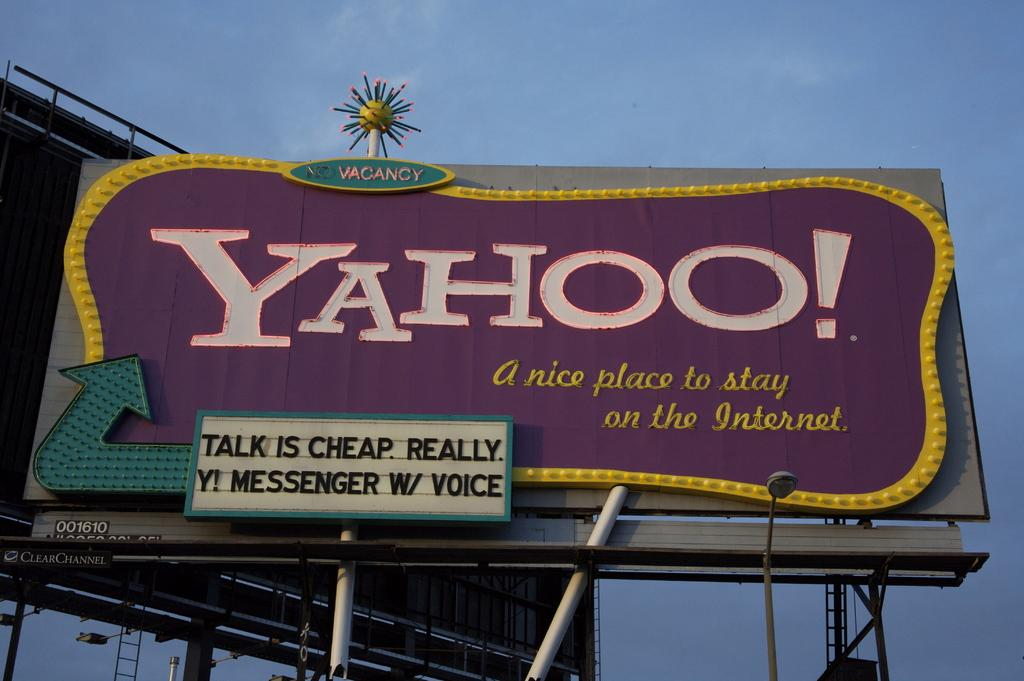<image>
Write a terse but informative summary of the picture. A Yahoo logo can be seen on a large sign with a blue sky in the background. 